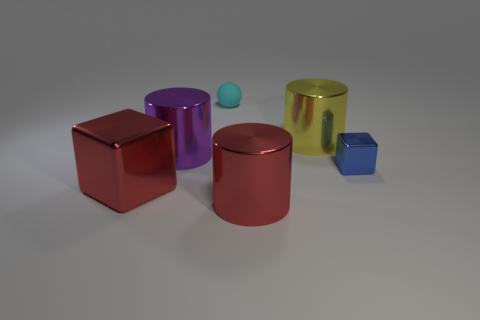What number of other things are the same color as the matte object?
Your answer should be compact. 0. Are there the same number of big yellow metallic cylinders to the right of the big block and blue metallic objects?
Your answer should be very brief. Yes. There is a small blue shiny cube on the right side of the object that is behind the yellow object; how many small blue things are in front of it?
Keep it short and to the point. 0. Is there any other thing that has the same size as the cyan rubber ball?
Offer a very short reply. Yes. Do the yellow thing and the shiny cube right of the big red shiny cylinder have the same size?
Provide a succinct answer. No. How many yellow objects are there?
Your answer should be compact. 1. Does the cube left of the blue object have the same size as the cylinder that is to the left of the cyan thing?
Your answer should be very brief. Yes. What is the color of the other shiny object that is the same shape as the tiny blue shiny object?
Make the answer very short. Red. Is the blue thing the same shape as the cyan matte object?
Provide a short and direct response. No. There is another object that is the same shape as the small blue object; what is its size?
Ensure brevity in your answer.  Large. 